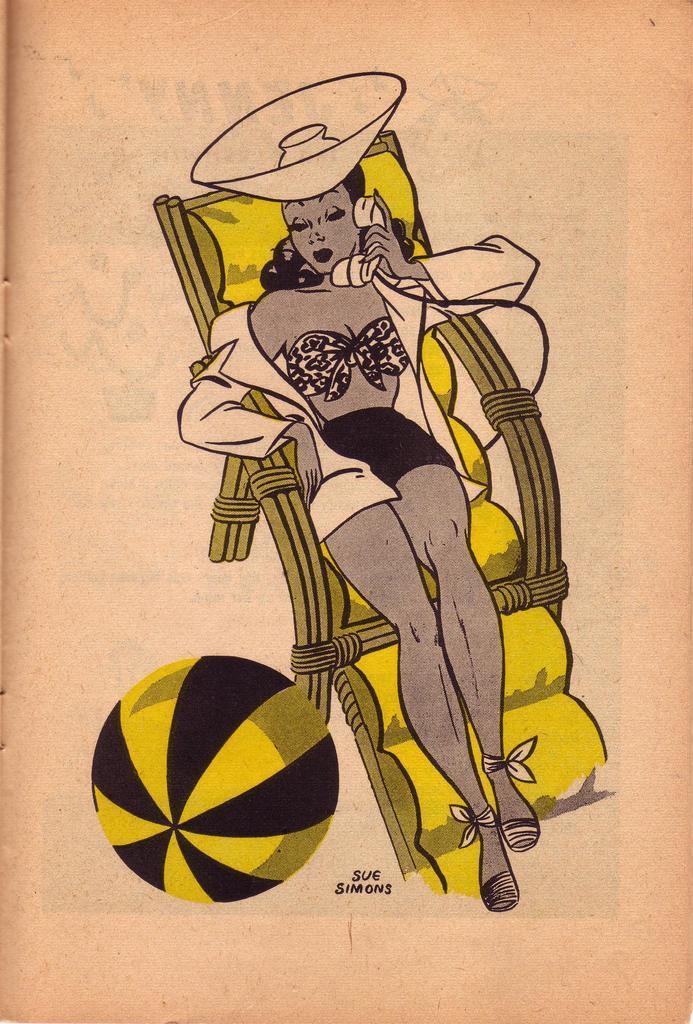Please provide a concise description of this image. In this I can see an edited photo in which a woman sitting on chair, holding a phone, wearing a cap, beside the chair there might be the wall. 